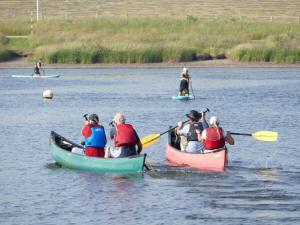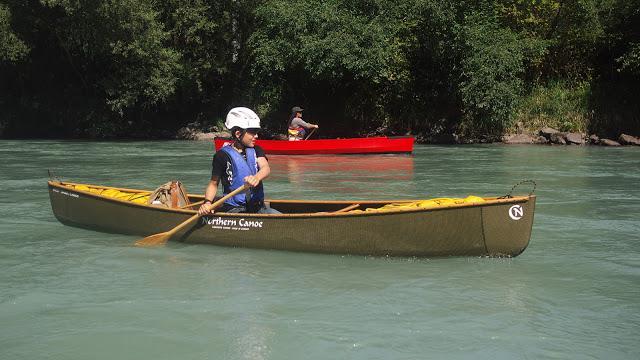The first image is the image on the left, the second image is the image on the right. Evaluate the accuracy of this statement regarding the images: "There is exactly one boat in the image on the right.". Is it true? Answer yes or no. No. 